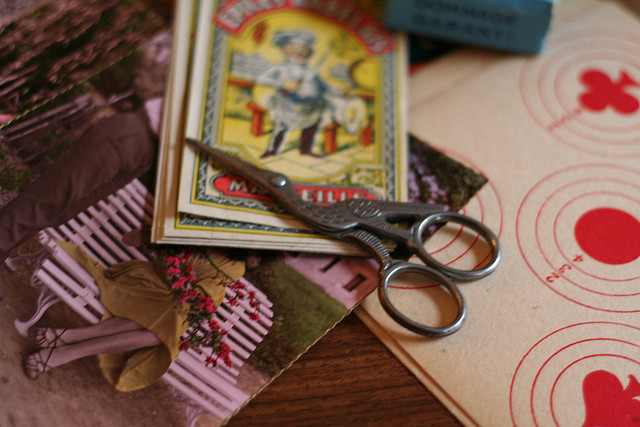Extract all visible text content from this image. 2 3 2 